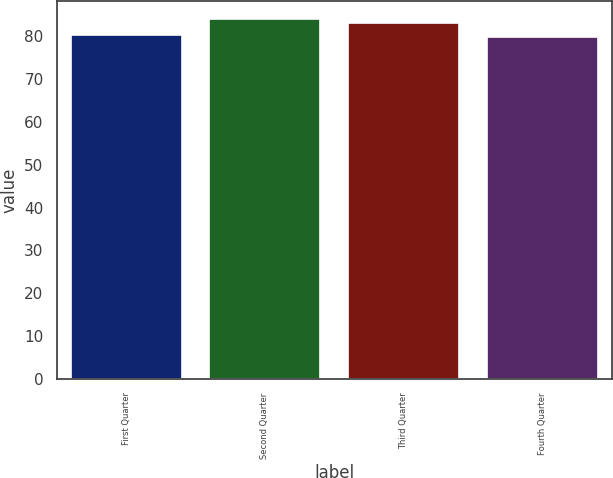Convert chart to OTSL. <chart><loc_0><loc_0><loc_500><loc_500><bar_chart><fcel>First Quarter<fcel>Second Quarter<fcel>Third Quarter<fcel>Fourth Quarter<nl><fcel>80.16<fcel>83.99<fcel>83<fcel>79.72<nl></chart> 